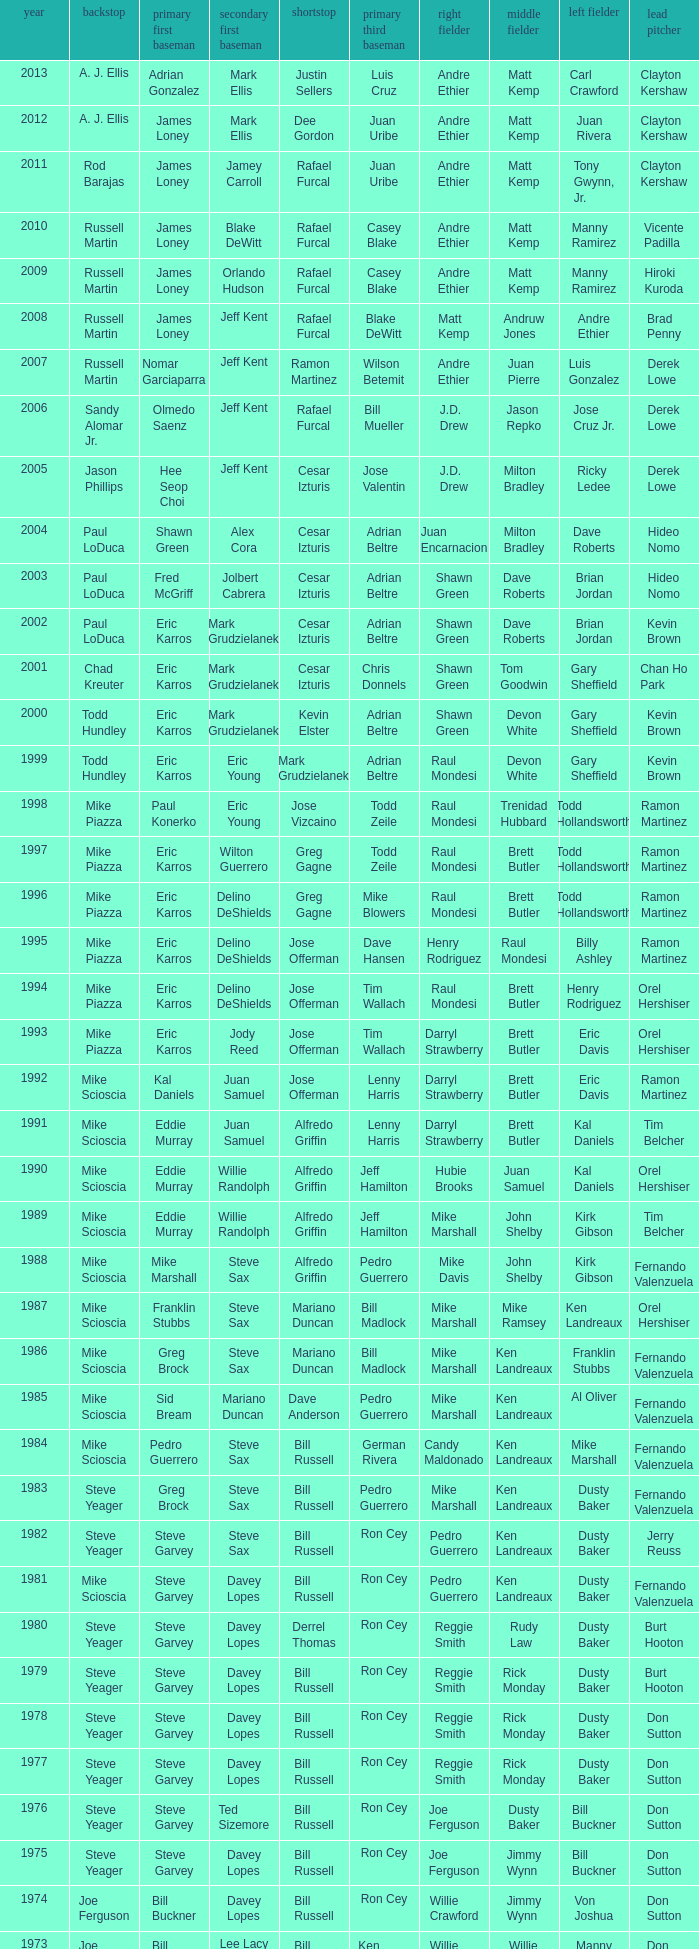Who played 2nd base when nomar garciaparra was at 1st base? Jeff Kent. 